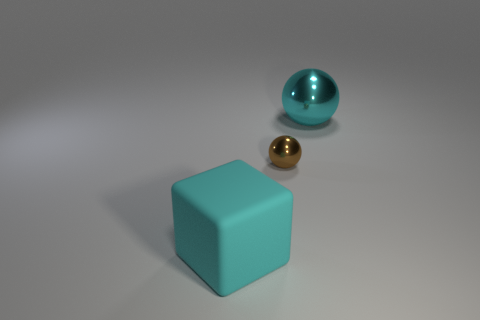Can you describe the texture and appearance of the objects in the image? Certainly! In the image, there are three objects, each with distinct textures. The large turquoise cube has a matte finish, which means it reflects light softly and has a non-glossy surface. The small sphere beside it has a polished, reflective gold surface, giving it a shiny appearance. Lastly, the teal ball on the far right has a glossy finish as well but with a noticeable sheen that's characteristic of a smoother, shinier surface compared to the gold sphere. 